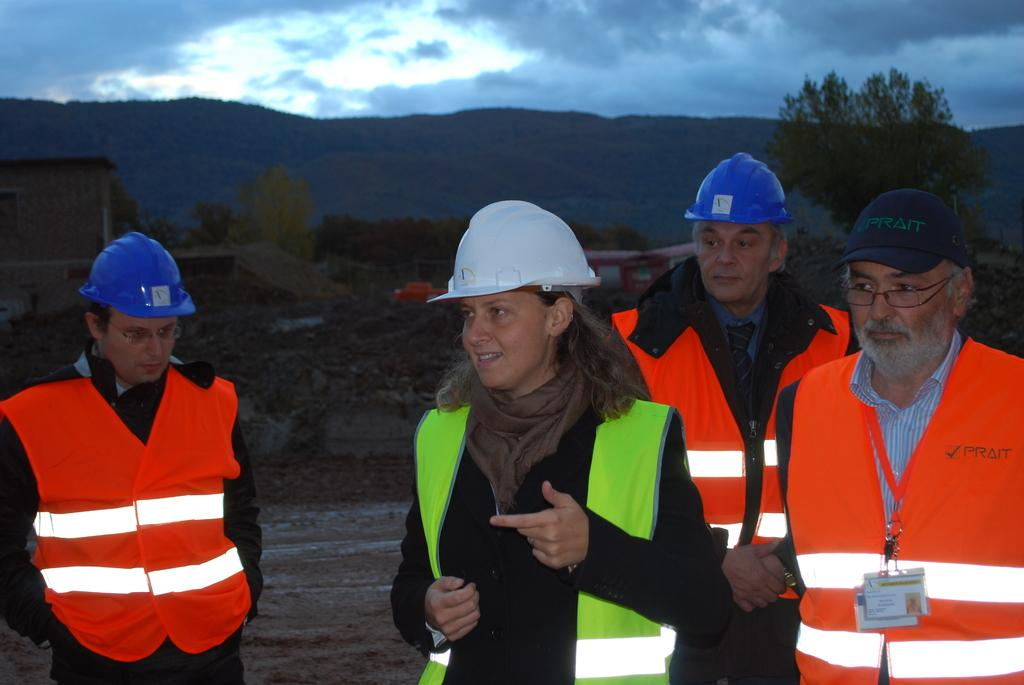What is happening in the image? There are people standing in the image. What can be seen in the background of the image? There is a green color plant in the background of the image. What color is the sky in the image? The sky is blue in the image. What type of nut is being used as a prop in the image? There is no nut present in the image. 